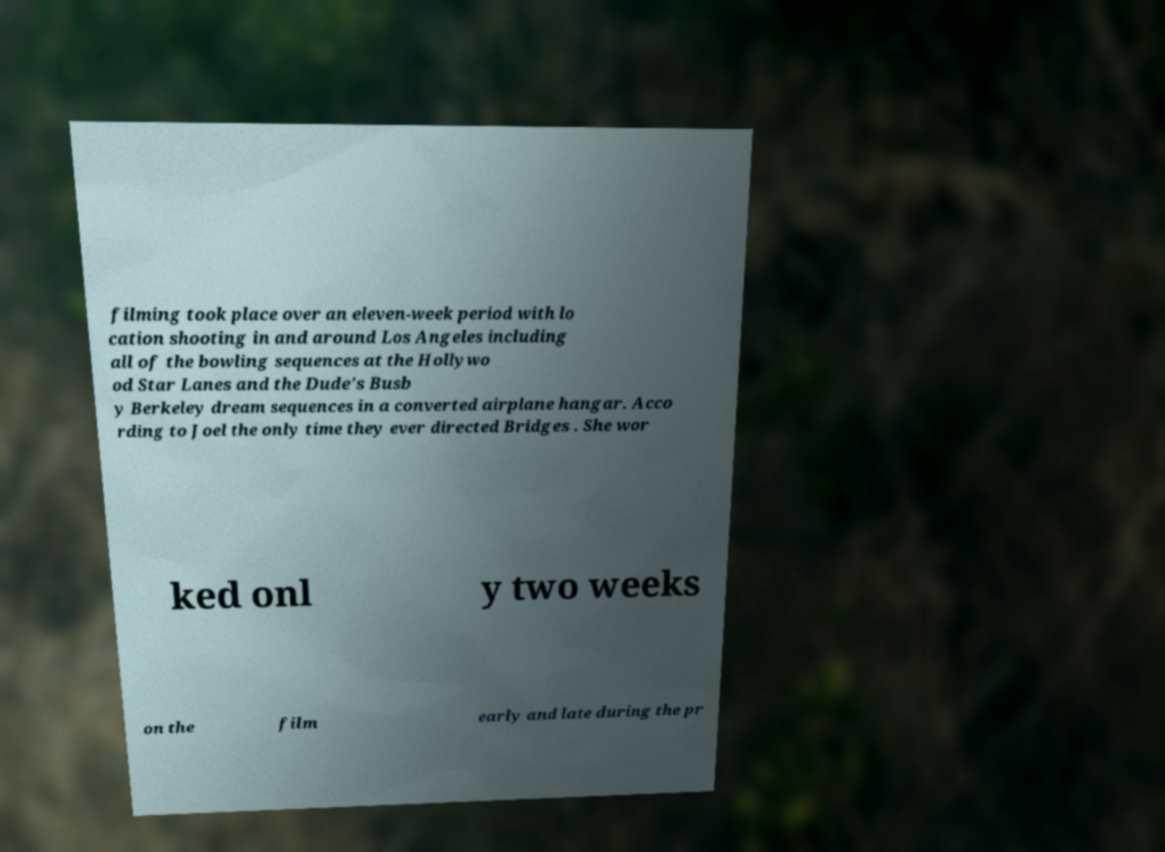Could you extract and type out the text from this image? filming took place over an eleven-week period with lo cation shooting in and around Los Angeles including all of the bowling sequences at the Hollywo od Star Lanes and the Dude's Busb y Berkeley dream sequences in a converted airplane hangar. Acco rding to Joel the only time they ever directed Bridges . She wor ked onl y two weeks on the film early and late during the pr 